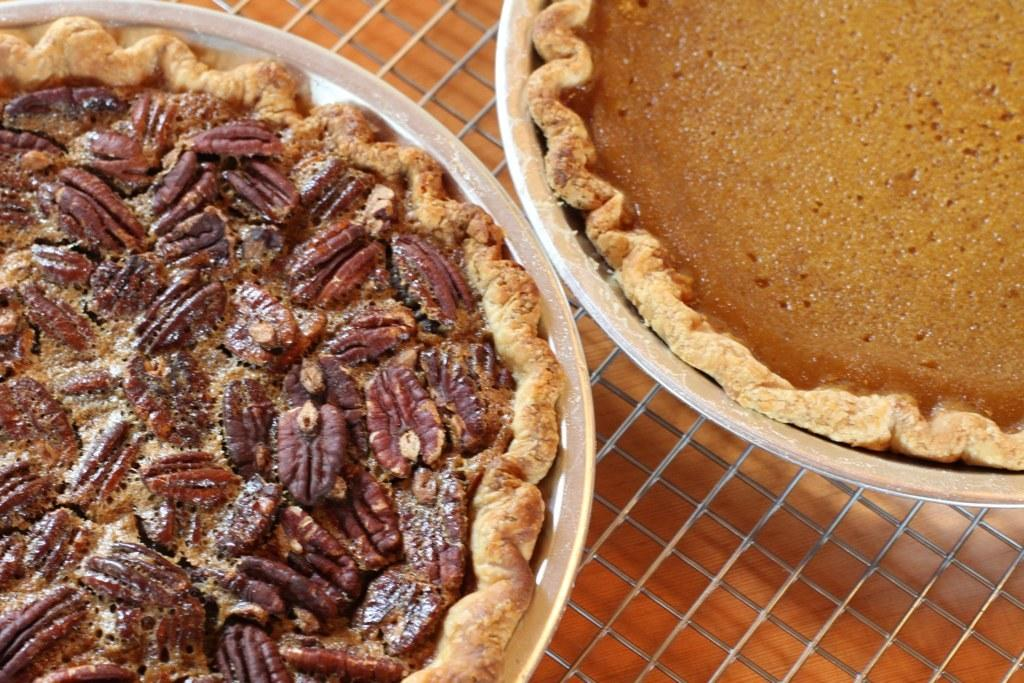What type of food can be seen in the image? The food in the image is in brown color. What is the color of the bowl containing the food? The bowl containing the food is in white color. What type of impulse can be seen in the image? There is no impulse present in the image; it features food in a bowl. What type of milk is being used in the image? There is no milk present in the image; it features food in a bowl. 